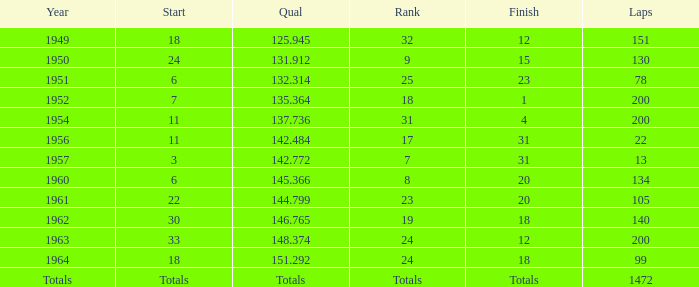Name the rank for laps less than 130 and year of 1951 25.0. 